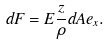<formula> <loc_0><loc_0><loc_500><loc_500>d F = E { \frac { z } { \rho } } d A e _ { x } .</formula> 